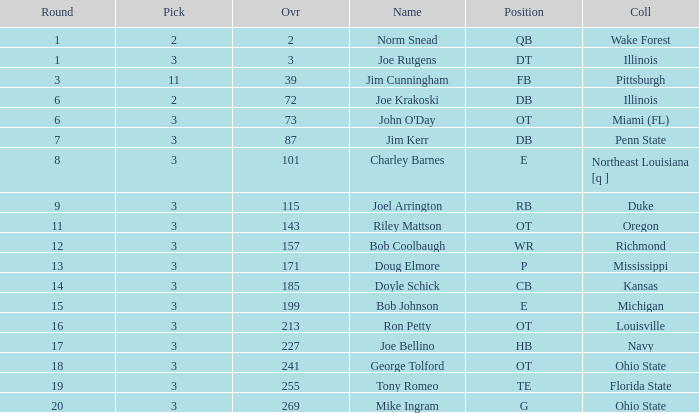How many overalls have charley barnes as the name, with a pick less than 3? None. 